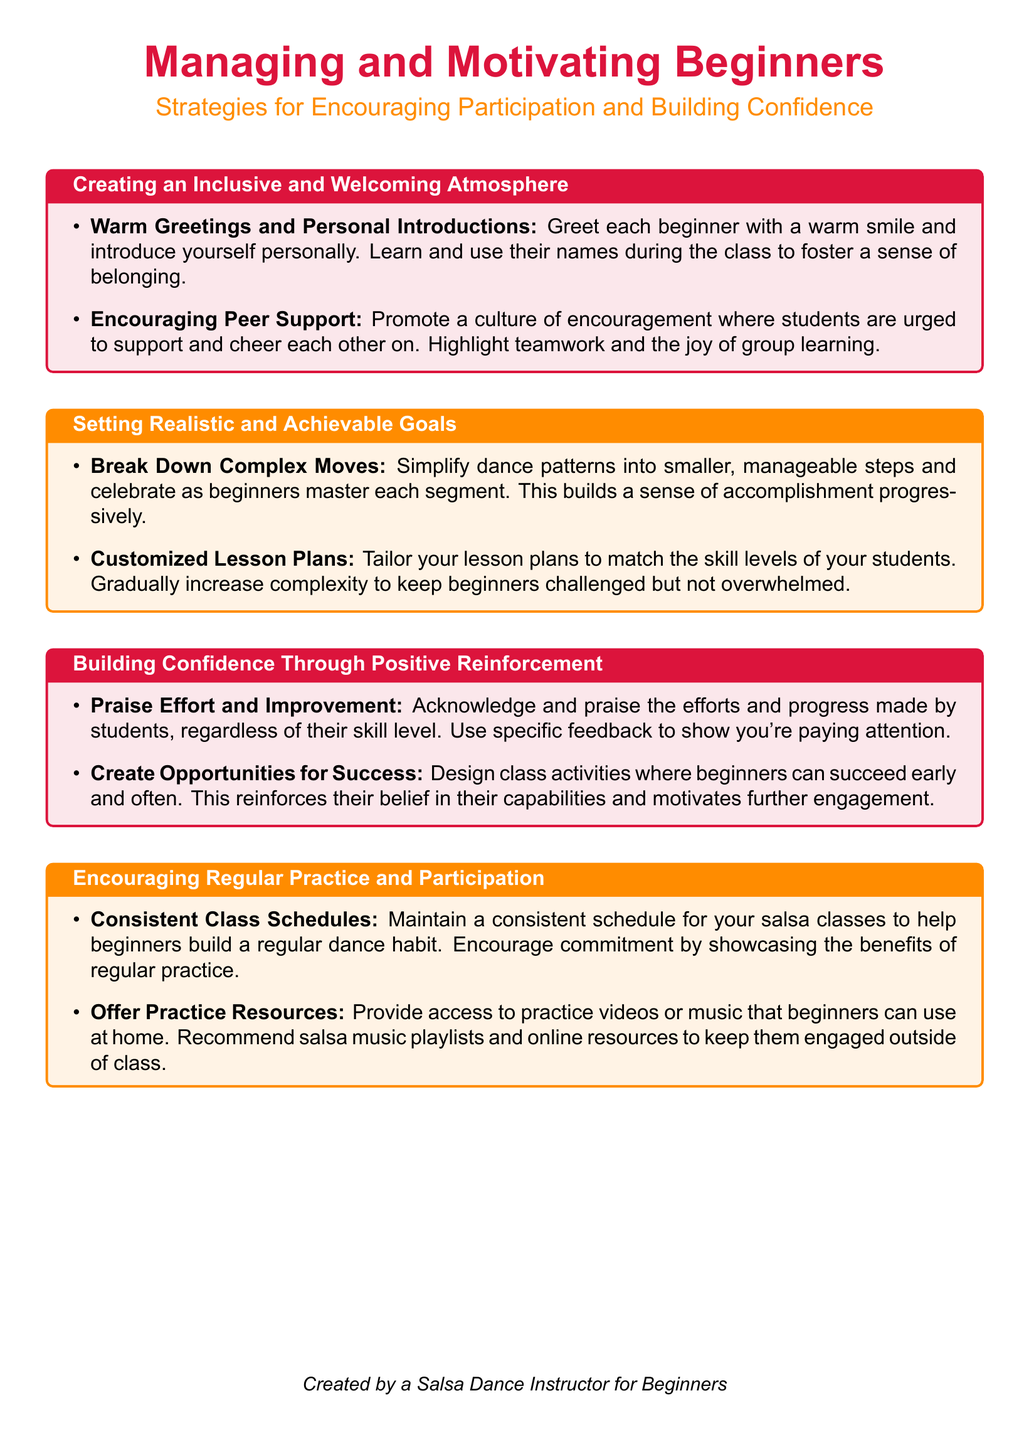What is the title of the document? The title of the document is prominently displayed at the top and is "Managing and Motivating Beginners."
Answer: Managing and Motivating Beginners What color is used for the section titles? The color used for section titles is specified in the document regarding design elements, which is salsared.
Answer: salsared What is one key strategy for creating an inclusive atmosphere? The document lists specific strategies for creating a welcoming environment, including warm greetings and personal introductions.
Answer: Warm Greetings and Personal Introductions How should complex moves be approached according to the guide? The guide emphasizes the importance of simplifying dance patterns into smaller, manageable steps for beginners.
Answer: Break Down Complex Moves How can instructors provide positive reinforcement? The document suggests that instructors should acknowledge and praise the efforts and progress made by students.
Answer: Praise Effort and Improvement What should be maintained to encourage regular practice? The consistency of class schedules is recommended to help beginners establish a regular dance habit.
Answer: Consistent Class Schedules What does the document suggest about offering resources? It indicates instructors should provide access to practice videos or music that beginners can use at home.
Answer: Offer Practice Resources What is highlighted as a benefit of regular practice? The document promotes showcasing the benefits of regular practice to encourage commitment from beginners.
Answer: Benefits of regular practice 